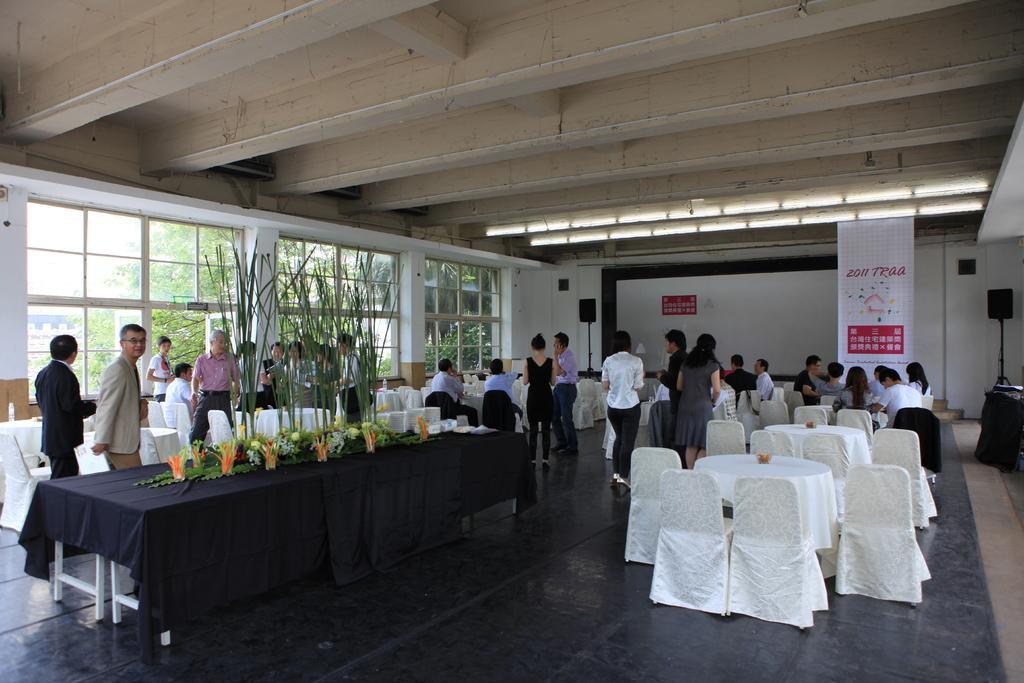Could you give a brief overview of what you see in this image? In this image it seems like it is a hall in which there are group of people who are sitting near the table. In the middle of hall there is a table on which there are flower vases,cups,grass on it. At the background there is a banner,speaker and the wall. At the top there is a light. To the left side there is a window through which we can see the trees. 